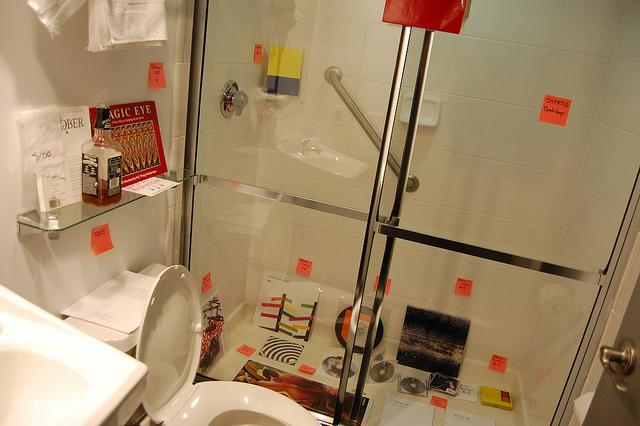What is near the bottle of alcohol? book 